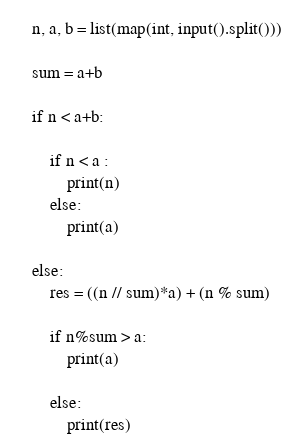<code> <loc_0><loc_0><loc_500><loc_500><_Python_>
n, a, b = list(map(int, input().split()))

sum = a+b

if n < a+b:

    if n < a :
        print(n)
    else:
        print(a)

else:
    res = ((n // sum)*a) + (n % sum)
    
    if n%sum > a: 
        print(a)

    else:
        print(res)
</code> 